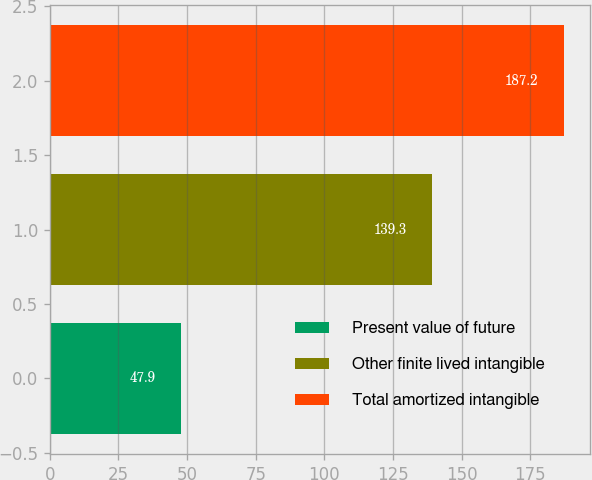Convert chart. <chart><loc_0><loc_0><loc_500><loc_500><bar_chart><fcel>Present value of future<fcel>Other finite lived intangible<fcel>Total amortized intangible<nl><fcel>47.9<fcel>139.3<fcel>187.2<nl></chart> 